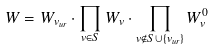<formula> <loc_0><loc_0><loc_500><loc_500>W = W _ { v _ { u r } } \cdot \prod _ { v \in S } W _ { v } \cdot \prod _ { v \notin S \cup \{ v _ { u r } \} } W _ { v } ^ { 0 }</formula> 